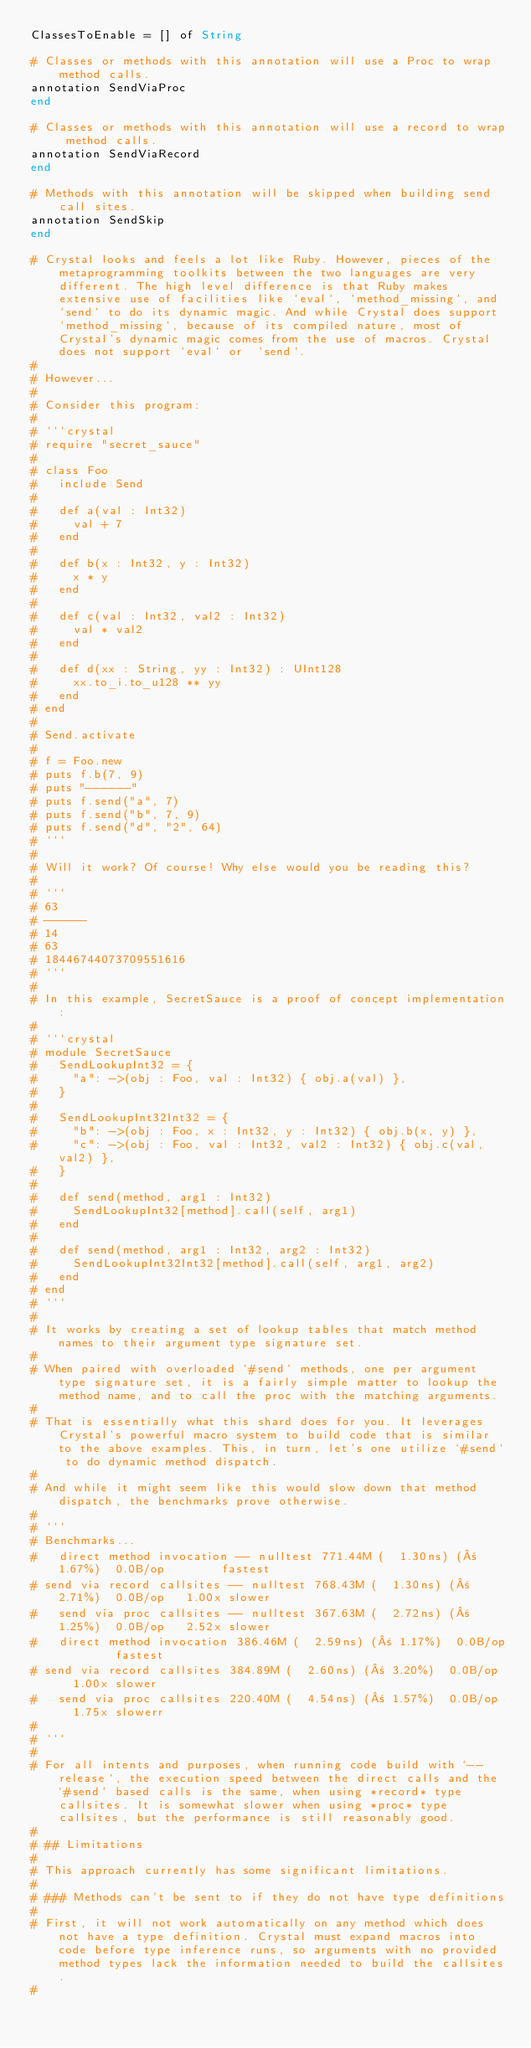<code> <loc_0><loc_0><loc_500><loc_500><_Crystal_>ClassesToEnable = [] of String

# Classes or methods with this annotation will use a Proc to wrap method calls.
annotation SendViaProc
end

# Classes or methods with this annotation will use a record to wrap method calls.
annotation SendViaRecord
end

# Methods with this annotation will be skipped when building send call sites.
annotation SendSkip
end

# Crystal looks and feels a lot like Ruby. However, pieces of the metaprogramming toolkits between the two languages are very different. The high level difference is that Ruby makes extensive use of facilities like `eval`, `method_missing`, and `send` to do its dynamic magic. And while Crystal does support `method_missing`, because of its compiled nature, most of Crystal's dynamic magic comes from the use of macros. Crystal does not support `eval` or  `send`.
#
# However...
#
# Consider this program:
#
# ```crystal
# require "secret_sauce"
#
# class Foo
#   include Send
#
#   def a(val : Int32)
#     val + 7
#   end
#
#   def b(x : Int32, y : Int32)
#     x * y
#   end
#
#   def c(val : Int32, val2 : Int32)
#     val * val2
#   end
#
#   def d(xx : String, yy : Int32) : UInt128
#     xx.to_i.to_u128 ** yy
#   end
# end
#
# Send.activate
#
# f = Foo.new
# puts f.b(7, 9)
# puts "------"
# puts f.send("a", 7)
# puts f.send("b", 7, 9)
# puts f.send("d", "2", 64)
# ```
#
# Will it work? Of course! Why else would you be reading this?
#
# ```
# 63
# ------
# 14
# 63
# 18446744073709551616
# ```
#
# In this example, SecretSauce is a proof of concept implementation:
#
# ```crystal
# module SecretSauce
#   SendLookupInt32 = {
#     "a": ->(obj : Foo, val : Int32) { obj.a(val) },
#   }
#
#   SendLookupInt32Int32 = {
#     "b": ->(obj : Foo, x : Int32, y : Int32) { obj.b(x, y) },
#     "c": ->(obj : Foo, val : Int32, val2 : Int32) { obj.c(val, val2) },
#   }
#
#   def send(method, arg1 : Int32)
#     SendLookupInt32[method].call(self, arg1)
#   end
#
#   def send(method, arg1 : Int32, arg2 : Int32)
#     SendLookupInt32Int32[method].call(self, arg1, arg2)
#   end
# end
# ```
#
# It works by creating a set of lookup tables that match method names to their argument type signature set.
#
# When paired with overloaded `#send` methods, one per argument type signature set, it is a fairly simple matter to lookup the method name, and to call the proc with the matching arguments.
#
# That is essentially what this shard does for you. It leverages Crystal's powerful macro system to build code that is similar to the above examples. This, in turn, let's one utilize `#send` to do dynamic method dispatch.
#
# And while it might seem like this would slow down that method dispatch, the benchmarks prove otherwise.
#
# ```
# Benchmarks...
#   direct method invocation -- nulltest 771.44M (  1.30ns) (± 1.67%)  0.0B/op        fastest
# send via record callsites -- nulltest 768.43M (  1.30ns) (± 2.71%)  0.0B/op   1.00x slower
#   send via proc callsites -- nulltest 367.63M (  2.72ns) (± 1.25%)  0.0B/op   2.52x slower
#   direct method invocation 386.46M (  2.59ns) (± 1.17%)  0.0B/op        fastest
# send via record callsites 384.89M (  2.60ns) (± 3.20%)  0.0B/op   1.00x slower
#   send via proc callsites 220.40M (  4.54ns) (± 1.57%)  0.0B/op   1.75x slowerr
#
# ```
#
# For all intents and purposes, when running code build with `--release`, the execution speed between the direct calls and the `#send` based calls is the same, when using *record* type callsites. It is somewhat slower when using *proc* type callsites, but the performance is still reasonably good.
#
# ## Limitations
#
# This approach currently has some significant limitations.
#
# ### Methods can't be sent to if they do not have type definitions
#
# First, it will not work automatically on any method which does not have a type definition. Crystal must expand macros into code before type inference runs, so arguments with no provided method types lack the information needed to build the callsites.
#</code> 